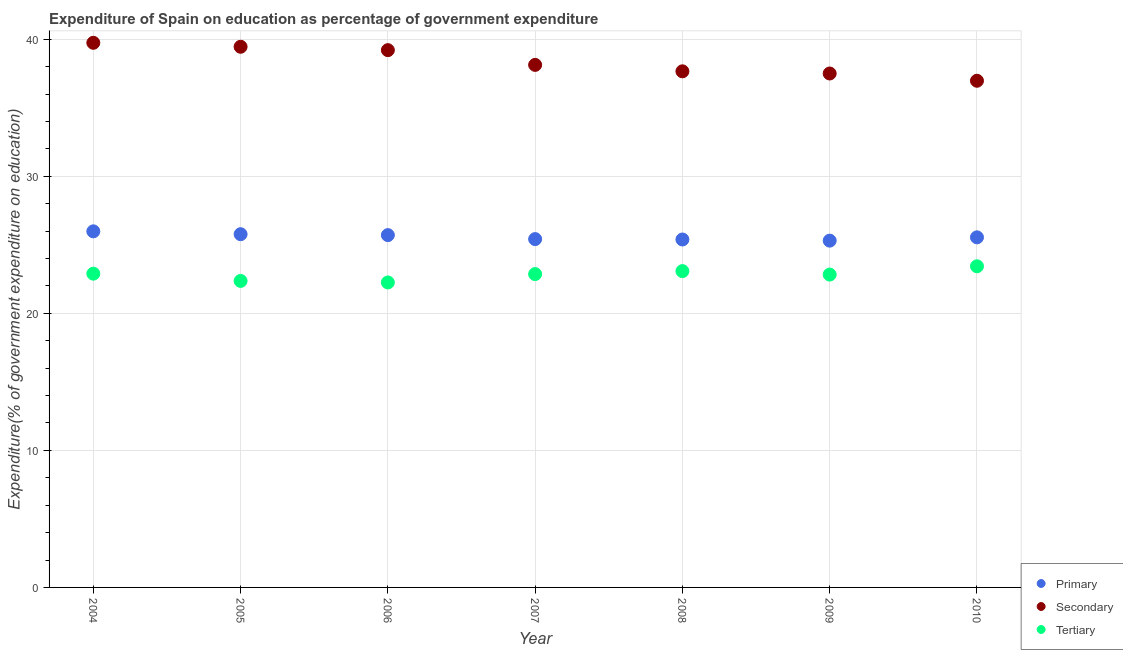Is the number of dotlines equal to the number of legend labels?
Give a very brief answer. Yes. What is the expenditure on secondary education in 2005?
Offer a terse response. 39.45. Across all years, what is the maximum expenditure on secondary education?
Provide a succinct answer. 39.74. Across all years, what is the minimum expenditure on primary education?
Offer a terse response. 25.3. In which year was the expenditure on primary education maximum?
Provide a succinct answer. 2004. In which year was the expenditure on tertiary education minimum?
Keep it short and to the point. 2006. What is the total expenditure on secondary education in the graph?
Offer a very short reply. 268.65. What is the difference between the expenditure on primary education in 2004 and that in 2008?
Offer a terse response. 0.59. What is the difference between the expenditure on primary education in 2006 and the expenditure on tertiary education in 2009?
Ensure brevity in your answer.  2.88. What is the average expenditure on secondary education per year?
Your answer should be very brief. 38.38. In the year 2008, what is the difference between the expenditure on tertiary education and expenditure on secondary education?
Ensure brevity in your answer.  -14.58. What is the ratio of the expenditure on primary education in 2007 to that in 2009?
Ensure brevity in your answer.  1. What is the difference between the highest and the second highest expenditure on secondary education?
Provide a succinct answer. 0.29. What is the difference between the highest and the lowest expenditure on tertiary education?
Your response must be concise. 1.18. In how many years, is the expenditure on tertiary education greater than the average expenditure on tertiary education taken over all years?
Give a very brief answer. 5. Is the sum of the expenditure on tertiary education in 2005 and 2009 greater than the maximum expenditure on secondary education across all years?
Your response must be concise. Yes. Is it the case that in every year, the sum of the expenditure on primary education and expenditure on secondary education is greater than the expenditure on tertiary education?
Make the answer very short. Yes. What is the difference between two consecutive major ticks on the Y-axis?
Ensure brevity in your answer.  10. Are the values on the major ticks of Y-axis written in scientific E-notation?
Ensure brevity in your answer.  No. Does the graph contain any zero values?
Provide a short and direct response. No. Does the graph contain grids?
Offer a terse response. Yes. Where does the legend appear in the graph?
Provide a short and direct response. Bottom right. How many legend labels are there?
Offer a terse response. 3. What is the title of the graph?
Provide a succinct answer. Expenditure of Spain on education as percentage of government expenditure. What is the label or title of the Y-axis?
Provide a short and direct response. Expenditure(% of government expenditure on education). What is the Expenditure(% of government expenditure on education) in Primary in 2004?
Your answer should be very brief. 25.98. What is the Expenditure(% of government expenditure on education) in Secondary in 2004?
Offer a very short reply. 39.74. What is the Expenditure(% of government expenditure on education) in Tertiary in 2004?
Ensure brevity in your answer.  22.89. What is the Expenditure(% of government expenditure on education) in Primary in 2005?
Your answer should be very brief. 25.77. What is the Expenditure(% of government expenditure on education) of Secondary in 2005?
Offer a terse response. 39.45. What is the Expenditure(% of government expenditure on education) in Tertiary in 2005?
Provide a short and direct response. 22.37. What is the Expenditure(% of government expenditure on education) in Primary in 2006?
Provide a short and direct response. 25.71. What is the Expenditure(% of government expenditure on education) in Secondary in 2006?
Keep it short and to the point. 39.2. What is the Expenditure(% of government expenditure on education) of Tertiary in 2006?
Your response must be concise. 22.25. What is the Expenditure(% of government expenditure on education) in Primary in 2007?
Provide a succinct answer. 25.42. What is the Expenditure(% of government expenditure on education) of Secondary in 2007?
Ensure brevity in your answer.  38.13. What is the Expenditure(% of government expenditure on education) of Tertiary in 2007?
Provide a short and direct response. 22.86. What is the Expenditure(% of government expenditure on education) in Primary in 2008?
Make the answer very short. 25.39. What is the Expenditure(% of government expenditure on education) of Secondary in 2008?
Your response must be concise. 37.66. What is the Expenditure(% of government expenditure on education) in Tertiary in 2008?
Ensure brevity in your answer.  23.08. What is the Expenditure(% of government expenditure on education) of Primary in 2009?
Offer a very short reply. 25.3. What is the Expenditure(% of government expenditure on education) in Secondary in 2009?
Your response must be concise. 37.5. What is the Expenditure(% of government expenditure on education) of Tertiary in 2009?
Offer a terse response. 22.83. What is the Expenditure(% of government expenditure on education) in Primary in 2010?
Make the answer very short. 25.54. What is the Expenditure(% of government expenditure on education) of Secondary in 2010?
Your response must be concise. 36.97. What is the Expenditure(% of government expenditure on education) of Tertiary in 2010?
Keep it short and to the point. 23.43. Across all years, what is the maximum Expenditure(% of government expenditure on education) of Primary?
Offer a terse response. 25.98. Across all years, what is the maximum Expenditure(% of government expenditure on education) of Secondary?
Your answer should be compact. 39.74. Across all years, what is the maximum Expenditure(% of government expenditure on education) in Tertiary?
Ensure brevity in your answer.  23.43. Across all years, what is the minimum Expenditure(% of government expenditure on education) of Primary?
Make the answer very short. 25.3. Across all years, what is the minimum Expenditure(% of government expenditure on education) of Secondary?
Your response must be concise. 36.97. Across all years, what is the minimum Expenditure(% of government expenditure on education) of Tertiary?
Provide a short and direct response. 22.25. What is the total Expenditure(% of government expenditure on education) of Primary in the graph?
Provide a succinct answer. 179.12. What is the total Expenditure(% of government expenditure on education) in Secondary in the graph?
Keep it short and to the point. 268.65. What is the total Expenditure(% of government expenditure on education) in Tertiary in the graph?
Your answer should be very brief. 159.72. What is the difference between the Expenditure(% of government expenditure on education) of Primary in 2004 and that in 2005?
Offer a very short reply. 0.21. What is the difference between the Expenditure(% of government expenditure on education) of Secondary in 2004 and that in 2005?
Offer a terse response. 0.29. What is the difference between the Expenditure(% of government expenditure on education) of Tertiary in 2004 and that in 2005?
Keep it short and to the point. 0.53. What is the difference between the Expenditure(% of government expenditure on education) of Primary in 2004 and that in 2006?
Make the answer very short. 0.28. What is the difference between the Expenditure(% of government expenditure on education) in Secondary in 2004 and that in 2006?
Give a very brief answer. 0.54. What is the difference between the Expenditure(% of government expenditure on education) in Tertiary in 2004 and that in 2006?
Offer a terse response. 0.64. What is the difference between the Expenditure(% of government expenditure on education) of Primary in 2004 and that in 2007?
Make the answer very short. 0.57. What is the difference between the Expenditure(% of government expenditure on education) in Secondary in 2004 and that in 2007?
Your answer should be compact. 1.61. What is the difference between the Expenditure(% of government expenditure on education) in Primary in 2004 and that in 2008?
Provide a succinct answer. 0.59. What is the difference between the Expenditure(% of government expenditure on education) in Secondary in 2004 and that in 2008?
Your answer should be very brief. 2.08. What is the difference between the Expenditure(% of government expenditure on education) of Tertiary in 2004 and that in 2008?
Provide a succinct answer. -0.19. What is the difference between the Expenditure(% of government expenditure on education) in Primary in 2004 and that in 2009?
Ensure brevity in your answer.  0.68. What is the difference between the Expenditure(% of government expenditure on education) of Secondary in 2004 and that in 2009?
Ensure brevity in your answer.  2.24. What is the difference between the Expenditure(% of government expenditure on education) in Tertiary in 2004 and that in 2009?
Ensure brevity in your answer.  0.06. What is the difference between the Expenditure(% of government expenditure on education) in Primary in 2004 and that in 2010?
Make the answer very short. 0.44. What is the difference between the Expenditure(% of government expenditure on education) in Secondary in 2004 and that in 2010?
Make the answer very short. 2.77. What is the difference between the Expenditure(% of government expenditure on education) of Tertiary in 2004 and that in 2010?
Provide a succinct answer. -0.54. What is the difference between the Expenditure(% of government expenditure on education) of Primary in 2005 and that in 2006?
Offer a terse response. 0.07. What is the difference between the Expenditure(% of government expenditure on education) of Secondary in 2005 and that in 2006?
Make the answer very short. 0.25. What is the difference between the Expenditure(% of government expenditure on education) in Tertiary in 2005 and that in 2006?
Provide a short and direct response. 0.11. What is the difference between the Expenditure(% of government expenditure on education) of Primary in 2005 and that in 2007?
Your response must be concise. 0.36. What is the difference between the Expenditure(% of government expenditure on education) of Secondary in 2005 and that in 2007?
Offer a very short reply. 1.32. What is the difference between the Expenditure(% of government expenditure on education) of Tertiary in 2005 and that in 2007?
Give a very brief answer. -0.5. What is the difference between the Expenditure(% of government expenditure on education) in Primary in 2005 and that in 2008?
Your answer should be compact. 0.39. What is the difference between the Expenditure(% of government expenditure on education) of Secondary in 2005 and that in 2008?
Give a very brief answer. 1.79. What is the difference between the Expenditure(% of government expenditure on education) in Tertiary in 2005 and that in 2008?
Ensure brevity in your answer.  -0.71. What is the difference between the Expenditure(% of government expenditure on education) in Primary in 2005 and that in 2009?
Offer a very short reply. 0.47. What is the difference between the Expenditure(% of government expenditure on education) of Secondary in 2005 and that in 2009?
Ensure brevity in your answer.  1.95. What is the difference between the Expenditure(% of government expenditure on education) of Tertiary in 2005 and that in 2009?
Provide a succinct answer. -0.46. What is the difference between the Expenditure(% of government expenditure on education) of Primary in 2005 and that in 2010?
Your answer should be very brief. 0.23. What is the difference between the Expenditure(% of government expenditure on education) of Secondary in 2005 and that in 2010?
Your answer should be compact. 2.48. What is the difference between the Expenditure(% of government expenditure on education) of Tertiary in 2005 and that in 2010?
Your response must be concise. -1.07. What is the difference between the Expenditure(% of government expenditure on education) of Primary in 2006 and that in 2007?
Provide a succinct answer. 0.29. What is the difference between the Expenditure(% of government expenditure on education) of Secondary in 2006 and that in 2007?
Ensure brevity in your answer.  1.08. What is the difference between the Expenditure(% of government expenditure on education) in Tertiary in 2006 and that in 2007?
Make the answer very short. -0.61. What is the difference between the Expenditure(% of government expenditure on education) in Primary in 2006 and that in 2008?
Your response must be concise. 0.32. What is the difference between the Expenditure(% of government expenditure on education) of Secondary in 2006 and that in 2008?
Keep it short and to the point. 1.54. What is the difference between the Expenditure(% of government expenditure on education) in Tertiary in 2006 and that in 2008?
Your answer should be very brief. -0.83. What is the difference between the Expenditure(% of government expenditure on education) in Primary in 2006 and that in 2009?
Your response must be concise. 0.4. What is the difference between the Expenditure(% of government expenditure on education) of Secondary in 2006 and that in 2009?
Provide a succinct answer. 1.7. What is the difference between the Expenditure(% of government expenditure on education) in Tertiary in 2006 and that in 2009?
Make the answer very short. -0.58. What is the difference between the Expenditure(% of government expenditure on education) of Primary in 2006 and that in 2010?
Ensure brevity in your answer.  0.16. What is the difference between the Expenditure(% of government expenditure on education) in Secondary in 2006 and that in 2010?
Your response must be concise. 2.23. What is the difference between the Expenditure(% of government expenditure on education) of Tertiary in 2006 and that in 2010?
Ensure brevity in your answer.  -1.18. What is the difference between the Expenditure(% of government expenditure on education) in Primary in 2007 and that in 2008?
Offer a terse response. 0.03. What is the difference between the Expenditure(% of government expenditure on education) of Secondary in 2007 and that in 2008?
Provide a short and direct response. 0.47. What is the difference between the Expenditure(% of government expenditure on education) of Tertiary in 2007 and that in 2008?
Provide a short and direct response. -0.22. What is the difference between the Expenditure(% of government expenditure on education) of Primary in 2007 and that in 2009?
Ensure brevity in your answer.  0.11. What is the difference between the Expenditure(% of government expenditure on education) of Secondary in 2007 and that in 2009?
Your answer should be very brief. 0.63. What is the difference between the Expenditure(% of government expenditure on education) of Tertiary in 2007 and that in 2009?
Your answer should be very brief. 0.03. What is the difference between the Expenditure(% of government expenditure on education) of Primary in 2007 and that in 2010?
Ensure brevity in your answer.  -0.13. What is the difference between the Expenditure(% of government expenditure on education) of Secondary in 2007 and that in 2010?
Provide a succinct answer. 1.16. What is the difference between the Expenditure(% of government expenditure on education) in Tertiary in 2007 and that in 2010?
Provide a short and direct response. -0.57. What is the difference between the Expenditure(% of government expenditure on education) in Primary in 2008 and that in 2009?
Provide a succinct answer. 0.08. What is the difference between the Expenditure(% of government expenditure on education) of Secondary in 2008 and that in 2009?
Ensure brevity in your answer.  0.16. What is the difference between the Expenditure(% of government expenditure on education) of Tertiary in 2008 and that in 2009?
Make the answer very short. 0.25. What is the difference between the Expenditure(% of government expenditure on education) in Primary in 2008 and that in 2010?
Make the answer very short. -0.16. What is the difference between the Expenditure(% of government expenditure on education) in Secondary in 2008 and that in 2010?
Offer a terse response. 0.69. What is the difference between the Expenditure(% of government expenditure on education) in Tertiary in 2008 and that in 2010?
Provide a succinct answer. -0.35. What is the difference between the Expenditure(% of government expenditure on education) in Primary in 2009 and that in 2010?
Your answer should be compact. -0.24. What is the difference between the Expenditure(% of government expenditure on education) in Secondary in 2009 and that in 2010?
Provide a succinct answer. 0.53. What is the difference between the Expenditure(% of government expenditure on education) in Tertiary in 2009 and that in 2010?
Your response must be concise. -0.6. What is the difference between the Expenditure(% of government expenditure on education) of Primary in 2004 and the Expenditure(% of government expenditure on education) of Secondary in 2005?
Your response must be concise. -13.47. What is the difference between the Expenditure(% of government expenditure on education) in Primary in 2004 and the Expenditure(% of government expenditure on education) in Tertiary in 2005?
Your answer should be very brief. 3.62. What is the difference between the Expenditure(% of government expenditure on education) in Secondary in 2004 and the Expenditure(% of government expenditure on education) in Tertiary in 2005?
Ensure brevity in your answer.  17.37. What is the difference between the Expenditure(% of government expenditure on education) in Primary in 2004 and the Expenditure(% of government expenditure on education) in Secondary in 2006?
Provide a succinct answer. -13.22. What is the difference between the Expenditure(% of government expenditure on education) in Primary in 2004 and the Expenditure(% of government expenditure on education) in Tertiary in 2006?
Give a very brief answer. 3.73. What is the difference between the Expenditure(% of government expenditure on education) in Secondary in 2004 and the Expenditure(% of government expenditure on education) in Tertiary in 2006?
Offer a very short reply. 17.49. What is the difference between the Expenditure(% of government expenditure on education) in Primary in 2004 and the Expenditure(% of government expenditure on education) in Secondary in 2007?
Offer a terse response. -12.15. What is the difference between the Expenditure(% of government expenditure on education) in Primary in 2004 and the Expenditure(% of government expenditure on education) in Tertiary in 2007?
Provide a short and direct response. 3.12. What is the difference between the Expenditure(% of government expenditure on education) of Secondary in 2004 and the Expenditure(% of government expenditure on education) of Tertiary in 2007?
Make the answer very short. 16.88. What is the difference between the Expenditure(% of government expenditure on education) in Primary in 2004 and the Expenditure(% of government expenditure on education) in Secondary in 2008?
Keep it short and to the point. -11.68. What is the difference between the Expenditure(% of government expenditure on education) of Primary in 2004 and the Expenditure(% of government expenditure on education) of Tertiary in 2008?
Offer a terse response. 2.9. What is the difference between the Expenditure(% of government expenditure on education) in Secondary in 2004 and the Expenditure(% of government expenditure on education) in Tertiary in 2008?
Your answer should be very brief. 16.66. What is the difference between the Expenditure(% of government expenditure on education) in Primary in 2004 and the Expenditure(% of government expenditure on education) in Secondary in 2009?
Give a very brief answer. -11.52. What is the difference between the Expenditure(% of government expenditure on education) in Primary in 2004 and the Expenditure(% of government expenditure on education) in Tertiary in 2009?
Your answer should be very brief. 3.15. What is the difference between the Expenditure(% of government expenditure on education) of Secondary in 2004 and the Expenditure(% of government expenditure on education) of Tertiary in 2009?
Your response must be concise. 16.91. What is the difference between the Expenditure(% of government expenditure on education) of Primary in 2004 and the Expenditure(% of government expenditure on education) of Secondary in 2010?
Your answer should be compact. -10.99. What is the difference between the Expenditure(% of government expenditure on education) in Primary in 2004 and the Expenditure(% of government expenditure on education) in Tertiary in 2010?
Your answer should be compact. 2.55. What is the difference between the Expenditure(% of government expenditure on education) of Secondary in 2004 and the Expenditure(% of government expenditure on education) of Tertiary in 2010?
Give a very brief answer. 16.31. What is the difference between the Expenditure(% of government expenditure on education) of Primary in 2005 and the Expenditure(% of government expenditure on education) of Secondary in 2006?
Provide a short and direct response. -13.43. What is the difference between the Expenditure(% of government expenditure on education) of Primary in 2005 and the Expenditure(% of government expenditure on education) of Tertiary in 2006?
Provide a short and direct response. 3.52. What is the difference between the Expenditure(% of government expenditure on education) in Secondary in 2005 and the Expenditure(% of government expenditure on education) in Tertiary in 2006?
Provide a succinct answer. 17.2. What is the difference between the Expenditure(% of government expenditure on education) in Primary in 2005 and the Expenditure(% of government expenditure on education) in Secondary in 2007?
Offer a very short reply. -12.35. What is the difference between the Expenditure(% of government expenditure on education) of Primary in 2005 and the Expenditure(% of government expenditure on education) of Tertiary in 2007?
Your response must be concise. 2.91. What is the difference between the Expenditure(% of government expenditure on education) of Secondary in 2005 and the Expenditure(% of government expenditure on education) of Tertiary in 2007?
Offer a terse response. 16.59. What is the difference between the Expenditure(% of government expenditure on education) in Primary in 2005 and the Expenditure(% of government expenditure on education) in Secondary in 2008?
Keep it short and to the point. -11.88. What is the difference between the Expenditure(% of government expenditure on education) of Primary in 2005 and the Expenditure(% of government expenditure on education) of Tertiary in 2008?
Give a very brief answer. 2.69. What is the difference between the Expenditure(% of government expenditure on education) of Secondary in 2005 and the Expenditure(% of government expenditure on education) of Tertiary in 2008?
Make the answer very short. 16.37. What is the difference between the Expenditure(% of government expenditure on education) in Primary in 2005 and the Expenditure(% of government expenditure on education) in Secondary in 2009?
Ensure brevity in your answer.  -11.73. What is the difference between the Expenditure(% of government expenditure on education) of Primary in 2005 and the Expenditure(% of government expenditure on education) of Tertiary in 2009?
Provide a succinct answer. 2.95. What is the difference between the Expenditure(% of government expenditure on education) in Secondary in 2005 and the Expenditure(% of government expenditure on education) in Tertiary in 2009?
Your answer should be very brief. 16.62. What is the difference between the Expenditure(% of government expenditure on education) of Primary in 2005 and the Expenditure(% of government expenditure on education) of Secondary in 2010?
Give a very brief answer. -11.2. What is the difference between the Expenditure(% of government expenditure on education) of Primary in 2005 and the Expenditure(% of government expenditure on education) of Tertiary in 2010?
Provide a succinct answer. 2.34. What is the difference between the Expenditure(% of government expenditure on education) of Secondary in 2005 and the Expenditure(% of government expenditure on education) of Tertiary in 2010?
Your answer should be compact. 16.02. What is the difference between the Expenditure(% of government expenditure on education) of Primary in 2006 and the Expenditure(% of government expenditure on education) of Secondary in 2007?
Your response must be concise. -12.42. What is the difference between the Expenditure(% of government expenditure on education) in Primary in 2006 and the Expenditure(% of government expenditure on education) in Tertiary in 2007?
Your answer should be compact. 2.84. What is the difference between the Expenditure(% of government expenditure on education) of Secondary in 2006 and the Expenditure(% of government expenditure on education) of Tertiary in 2007?
Give a very brief answer. 16.34. What is the difference between the Expenditure(% of government expenditure on education) in Primary in 2006 and the Expenditure(% of government expenditure on education) in Secondary in 2008?
Your response must be concise. -11.95. What is the difference between the Expenditure(% of government expenditure on education) of Primary in 2006 and the Expenditure(% of government expenditure on education) of Tertiary in 2008?
Keep it short and to the point. 2.63. What is the difference between the Expenditure(% of government expenditure on education) of Secondary in 2006 and the Expenditure(% of government expenditure on education) of Tertiary in 2008?
Offer a terse response. 16.12. What is the difference between the Expenditure(% of government expenditure on education) in Primary in 2006 and the Expenditure(% of government expenditure on education) in Secondary in 2009?
Ensure brevity in your answer.  -11.79. What is the difference between the Expenditure(% of government expenditure on education) of Primary in 2006 and the Expenditure(% of government expenditure on education) of Tertiary in 2009?
Your answer should be compact. 2.88. What is the difference between the Expenditure(% of government expenditure on education) of Secondary in 2006 and the Expenditure(% of government expenditure on education) of Tertiary in 2009?
Provide a short and direct response. 16.37. What is the difference between the Expenditure(% of government expenditure on education) of Primary in 2006 and the Expenditure(% of government expenditure on education) of Secondary in 2010?
Your response must be concise. -11.26. What is the difference between the Expenditure(% of government expenditure on education) of Primary in 2006 and the Expenditure(% of government expenditure on education) of Tertiary in 2010?
Offer a very short reply. 2.27. What is the difference between the Expenditure(% of government expenditure on education) of Secondary in 2006 and the Expenditure(% of government expenditure on education) of Tertiary in 2010?
Make the answer very short. 15.77. What is the difference between the Expenditure(% of government expenditure on education) of Primary in 2007 and the Expenditure(% of government expenditure on education) of Secondary in 2008?
Ensure brevity in your answer.  -12.24. What is the difference between the Expenditure(% of government expenditure on education) in Primary in 2007 and the Expenditure(% of government expenditure on education) in Tertiary in 2008?
Keep it short and to the point. 2.34. What is the difference between the Expenditure(% of government expenditure on education) of Secondary in 2007 and the Expenditure(% of government expenditure on education) of Tertiary in 2008?
Provide a short and direct response. 15.05. What is the difference between the Expenditure(% of government expenditure on education) of Primary in 2007 and the Expenditure(% of government expenditure on education) of Secondary in 2009?
Provide a succinct answer. -12.08. What is the difference between the Expenditure(% of government expenditure on education) of Primary in 2007 and the Expenditure(% of government expenditure on education) of Tertiary in 2009?
Give a very brief answer. 2.59. What is the difference between the Expenditure(% of government expenditure on education) of Secondary in 2007 and the Expenditure(% of government expenditure on education) of Tertiary in 2009?
Ensure brevity in your answer.  15.3. What is the difference between the Expenditure(% of government expenditure on education) in Primary in 2007 and the Expenditure(% of government expenditure on education) in Secondary in 2010?
Your response must be concise. -11.55. What is the difference between the Expenditure(% of government expenditure on education) in Primary in 2007 and the Expenditure(% of government expenditure on education) in Tertiary in 2010?
Ensure brevity in your answer.  1.98. What is the difference between the Expenditure(% of government expenditure on education) in Secondary in 2007 and the Expenditure(% of government expenditure on education) in Tertiary in 2010?
Provide a short and direct response. 14.7. What is the difference between the Expenditure(% of government expenditure on education) of Primary in 2008 and the Expenditure(% of government expenditure on education) of Secondary in 2009?
Your response must be concise. -12.11. What is the difference between the Expenditure(% of government expenditure on education) in Primary in 2008 and the Expenditure(% of government expenditure on education) in Tertiary in 2009?
Your answer should be compact. 2.56. What is the difference between the Expenditure(% of government expenditure on education) in Secondary in 2008 and the Expenditure(% of government expenditure on education) in Tertiary in 2009?
Provide a short and direct response. 14.83. What is the difference between the Expenditure(% of government expenditure on education) of Primary in 2008 and the Expenditure(% of government expenditure on education) of Secondary in 2010?
Your answer should be compact. -11.58. What is the difference between the Expenditure(% of government expenditure on education) of Primary in 2008 and the Expenditure(% of government expenditure on education) of Tertiary in 2010?
Give a very brief answer. 1.95. What is the difference between the Expenditure(% of government expenditure on education) of Secondary in 2008 and the Expenditure(% of government expenditure on education) of Tertiary in 2010?
Your answer should be very brief. 14.23. What is the difference between the Expenditure(% of government expenditure on education) in Primary in 2009 and the Expenditure(% of government expenditure on education) in Secondary in 2010?
Offer a terse response. -11.67. What is the difference between the Expenditure(% of government expenditure on education) in Primary in 2009 and the Expenditure(% of government expenditure on education) in Tertiary in 2010?
Your response must be concise. 1.87. What is the difference between the Expenditure(% of government expenditure on education) of Secondary in 2009 and the Expenditure(% of government expenditure on education) of Tertiary in 2010?
Provide a short and direct response. 14.07. What is the average Expenditure(% of government expenditure on education) in Primary per year?
Provide a succinct answer. 25.59. What is the average Expenditure(% of government expenditure on education) of Secondary per year?
Provide a short and direct response. 38.38. What is the average Expenditure(% of government expenditure on education) in Tertiary per year?
Offer a terse response. 22.82. In the year 2004, what is the difference between the Expenditure(% of government expenditure on education) of Primary and Expenditure(% of government expenditure on education) of Secondary?
Keep it short and to the point. -13.76. In the year 2004, what is the difference between the Expenditure(% of government expenditure on education) of Primary and Expenditure(% of government expenditure on education) of Tertiary?
Provide a succinct answer. 3.09. In the year 2004, what is the difference between the Expenditure(% of government expenditure on education) in Secondary and Expenditure(% of government expenditure on education) in Tertiary?
Offer a very short reply. 16.85. In the year 2005, what is the difference between the Expenditure(% of government expenditure on education) of Primary and Expenditure(% of government expenditure on education) of Secondary?
Give a very brief answer. -13.68. In the year 2005, what is the difference between the Expenditure(% of government expenditure on education) in Primary and Expenditure(% of government expenditure on education) in Tertiary?
Your response must be concise. 3.41. In the year 2005, what is the difference between the Expenditure(% of government expenditure on education) in Secondary and Expenditure(% of government expenditure on education) in Tertiary?
Ensure brevity in your answer.  17.09. In the year 2006, what is the difference between the Expenditure(% of government expenditure on education) of Primary and Expenditure(% of government expenditure on education) of Secondary?
Provide a succinct answer. -13.5. In the year 2006, what is the difference between the Expenditure(% of government expenditure on education) of Primary and Expenditure(% of government expenditure on education) of Tertiary?
Provide a succinct answer. 3.45. In the year 2006, what is the difference between the Expenditure(% of government expenditure on education) of Secondary and Expenditure(% of government expenditure on education) of Tertiary?
Provide a short and direct response. 16.95. In the year 2007, what is the difference between the Expenditure(% of government expenditure on education) of Primary and Expenditure(% of government expenditure on education) of Secondary?
Ensure brevity in your answer.  -12.71. In the year 2007, what is the difference between the Expenditure(% of government expenditure on education) in Primary and Expenditure(% of government expenditure on education) in Tertiary?
Provide a succinct answer. 2.55. In the year 2007, what is the difference between the Expenditure(% of government expenditure on education) in Secondary and Expenditure(% of government expenditure on education) in Tertiary?
Give a very brief answer. 15.26. In the year 2008, what is the difference between the Expenditure(% of government expenditure on education) of Primary and Expenditure(% of government expenditure on education) of Secondary?
Provide a short and direct response. -12.27. In the year 2008, what is the difference between the Expenditure(% of government expenditure on education) of Primary and Expenditure(% of government expenditure on education) of Tertiary?
Offer a very short reply. 2.31. In the year 2008, what is the difference between the Expenditure(% of government expenditure on education) of Secondary and Expenditure(% of government expenditure on education) of Tertiary?
Provide a short and direct response. 14.58. In the year 2009, what is the difference between the Expenditure(% of government expenditure on education) of Primary and Expenditure(% of government expenditure on education) of Secondary?
Offer a very short reply. -12.2. In the year 2009, what is the difference between the Expenditure(% of government expenditure on education) of Primary and Expenditure(% of government expenditure on education) of Tertiary?
Make the answer very short. 2.47. In the year 2009, what is the difference between the Expenditure(% of government expenditure on education) in Secondary and Expenditure(% of government expenditure on education) in Tertiary?
Provide a succinct answer. 14.67. In the year 2010, what is the difference between the Expenditure(% of government expenditure on education) in Primary and Expenditure(% of government expenditure on education) in Secondary?
Keep it short and to the point. -11.43. In the year 2010, what is the difference between the Expenditure(% of government expenditure on education) in Primary and Expenditure(% of government expenditure on education) in Tertiary?
Ensure brevity in your answer.  2.11. In the year 2010, what is the difference between the Expenditure(% of government expenditure on education) of Secondary and Expenditure(% of government expenditure on education) of Tertiary?
Offer a very short reply. 13.54. What is the ratio of the Expenditure(% of government expenditure on education) in Secondary in 2004 to that in 2005?
Ensure brevity in your answer.  1.01. What is the ratio of the Expenditure(% of government expenditure on education) of Tertiary in 2004 to that in 2005?
Your response must be concise. 1.02. What is the ratio of the Expenditure(% of government expenditure on education) of Primary in 2004 to that in 2006?
Make the answer very short. 1.01. What is the ratio of the Expenditure(% of government expenditure on education) of Secondary in 2004 to that in 2006?
Keep it short and to the point. 1.01. What is the ratio of the Expenditure(% of government expenditure on education) of Tertiary in 2004 to that in 2006?
Offer a very short reply. 1.03. What is the ratio of the Expenditure(% of government expenditure on education) in Primary in 2004 to that in 2007?
Keep it short and to the point. 1.02. What is the ratio of the Expenditure(% of government expenditure on education) of Secondary in 2004 to that in 2007?
Provide a short and direct response. 1.04. What is the ratio of the Expenditure(% of government expenditure on education) in Tertiary in 2004 to that in 2007?
Provide a succinct answer. 1. What is the ratio of the Expenditure(% of government expenditure on education) in Primary in 2004 to that in 2008?
Offer a very short reply. 1.02. What is the ratio of the Expenditure(% of government expenditure on education) of Secondary in 2004 to that in 2008?
Give a very brief answer. 1.06. What is the ratio of the Expenditure(% of government expenditure on education) of Tertiary in 2004 to that in 2008?
Give a very brief answer. 0.99. What is the ratio of the Expenditure(% of government expenditure on education) in Primary in 2004 to that in 2009?
Ensure brevity in your answer.  1.03. What is the ratio of the Expenditure(% of government expenditure on education) in Secondary in 2004 to that in 2009?
Offer a very short reply. 1.06. What is the ratio of the Expenditure(% of government expenditure on education) of Tertiary in 2004 to that in 2009?
Make the answer very short. 1. What is the ratio of the Expenditure(% of government expenditure on education) in Primary in 2004 to that in 2010?
Provide a short and direct response. 1.02. What is the ratio of the Expenditure(% of government expenditure on education) of Secondary in 2004 to that in 2010?
Your response must be concise. 1.07. What is the ratio of the Expenditure(% of government expenditure on education) of Tertiary in 2004 to that in 2010?
Offer a very short reply. 0.98. What is the ratio of the Expenditure(% of government expenditure on education) of Secondary in 2005 to that in 2006?
Ensure brevity in your answer.  1.01. What is the ratio of the Expenditure(% of government expenditure on education) in Primary in 2005 to that in 2007?
Offer a very short reply. 1.01. What is the ratio of the Expenditure(% of government expenditure on education) of Secondary in 2005 to that in 2007?
Provide a succinct answer. 1.03. What is the ratio of the Expenditure(% of government expenditure on education) in Tertiary in 2005 to that in 2007?
Make the answer very short. 0.98. What is the ratio of the Expenditure(% of government expenditure on education) in Primary in 2005 to that in 2008?
Ensure brevity in your answer.  1.02. What is the ratio of the Expenditure(% of government expenditure on education) in Secondary in 2005 to that in 2008?
Offer a terse response. 1.05. What is the ratio of the Expenditure(% of government expenditure on education) of Primary in 2005 to that in 2009?
Your response must be concise. 1.02. What is the ratio of the Expenditure(% of government expenditure on education) in Secondary in 2005 to that in 2009?
Provide a short and direct response. 1.05. What is the ratio of the Expenditure(% of government expenditure on education) in Tertiary in 2005 to that in 2009?
Give a very brief answer. 0.98. What is the ratio of the Expenditure(% of government expenditure on education) in Secondary in 2005 to that in 2010?
Provide a short and direct response. 1.07. What is the ratio of the Expenditure(% of government expenditure on education) in Tertiary in 2005 to that in 2010?
Keep it short and to the point. 0.95. What is the ratio of the Expenditure(% of government expenditure on education) in Primary in 2006 to that in 2007?
Keep it short and to the point. 1.01. What is the ratio of the Expenditure(% of government expenditure on education) of Secondary in 2006 to that in 2007?
Ensure brevity in your answer.  1.03. What is the ratio of the Expenditure(% of government expenditure on education) in Tertiary in 2006 to that in 2007?
Make the answer very short. 0.97. What is the ratio of the Expenditure(% of government expenditure on education) of Primary in 2006 to that in 2008?
Ensure brevity in your answer.  1.01. What is the ratio of the Expenditure(% of government expenditure on education) in Secondary in 2006 to that in 2008?
Your response must be concise. 1.04. What is the ratio of the Expenditure(% of government expenditure on education) of Tertiary in 2006 to that in 2008?
Provide a succinct answer. 0.96. What is the ratio of the Expenditure(% of government expenditure on education) of Primary in 2006 to that in 2009?
Give a very brief answer. 1.02. What is the ratio of the Expenditure(% of government expenditure on education) of Secondary in 2006 to that in 2009?
Make the answer very short. 1.05. What is the ratio of the Expenditure(% of government expenditure on education) of Tertiary in 2006 to that in 2009?
Offer a very short reply. 0.97. What is the ratio of the Expenditure(% of government expenditure on education) of Primary in 2006 to that in 2010?
Give a very brief answer. 1.01. What is the ratio of the Expenditure(% of government expenditure on education) of Secondary in 2006 to that in 2010?
Your answer should be compact. 1.06. What is the ratio of the Expenditure(% of government expenditure on education) of Tertiary in 2006 to that in 2010?
Your response must be concise. 0.95. What is the ratio of the Expenditure(% of government expenditure on education) in Primary in 2007 to that in 2008?
Keep it short and to the point. 1. What is the ratio of the Expenditure(% of government expenditure on education) of Secondary in 2007 to that in 2008?
Your answer should be compact. 1.01. What is the ratio of the Expenditure(% of government expenditure on education) in Tertiary in 2007 to that in 2008?
Provide a short and direct response. 0.99. What is the ratio of the Expenditure(% of government expenditure on education) of Secondary in 2007 to that in 2009?
Provide a short and direct response. 1.02. What is the ratio of the Expenditure(% of government expenditure on education) of Secondary in 2007 to that in 2010?
Provide a succinct answer. 1.03. What is the ratio of the Expenditure(% of government expenditure on education) of Tertiary in 2007 to that in 2010?
Make the answer very short. 0.98. What is the ratio of the Expenditure(% of government expenditure on education) of Primary in 2008 to that in 2009?
Ensure brevity in your answer.  1. What is the ratio of the Expenditure(% of government expenditure on education) in Primary in 2008 to that in 2010?
Give a very brief answer. 0.99. What is the ratio of the Expenditure(% of government expenditure on education) in Secondary in 2008 to that in 2010?
Ensure brevity in your answer.  1.02. What is the ratio of the Expenditure(% of government expenditure on education) in Tertiary in 2008 to that in 2010?
Keep it short and to the point. 0.98. What is the ratio of the Expenditure(% of government expenditure on education) in Primary in 2009 to that in 2010?
Your answer should be compact. 0.99. What is the ratio of the Expenditure(% of government expenditure on education) in Secondary in 2009 to that in 2010?
Provide a succinct answer. 1.01. What is the ratio of the Expenditure(% of government expenditure on education) in Tertiary in 2009 to that in 2010?
Your answer should be compact. 0.97. What is the difference between the highest and the second highest Expenditure(% of government expenditure on education) in Primary?
Offer a very short reply. 0.21. What is the difference between the highest and the second highest Expenditure(% of government expenditure on education) in Secondary?
Your answer should be compact. 0.29. What is the difference between the highest and the second highest Expenditure(% of government expenditure on education) in Tertiary?
Keep it short and to the point. 0.35. What is the difference between the highest and the lowest Expenditure(% of government expenditure on education) in Primary?
Give a very brief answer. 0.68. What is the difference between the highest and the lowest Expenditure(% of government expenditure on education) of Secondary?
Your answer should be very brief. 2.77. What is the difference between the highest and the lowest Expenditure(% of government expenditure on education) in Tertiary?
Offer a terse response. 1.18. 